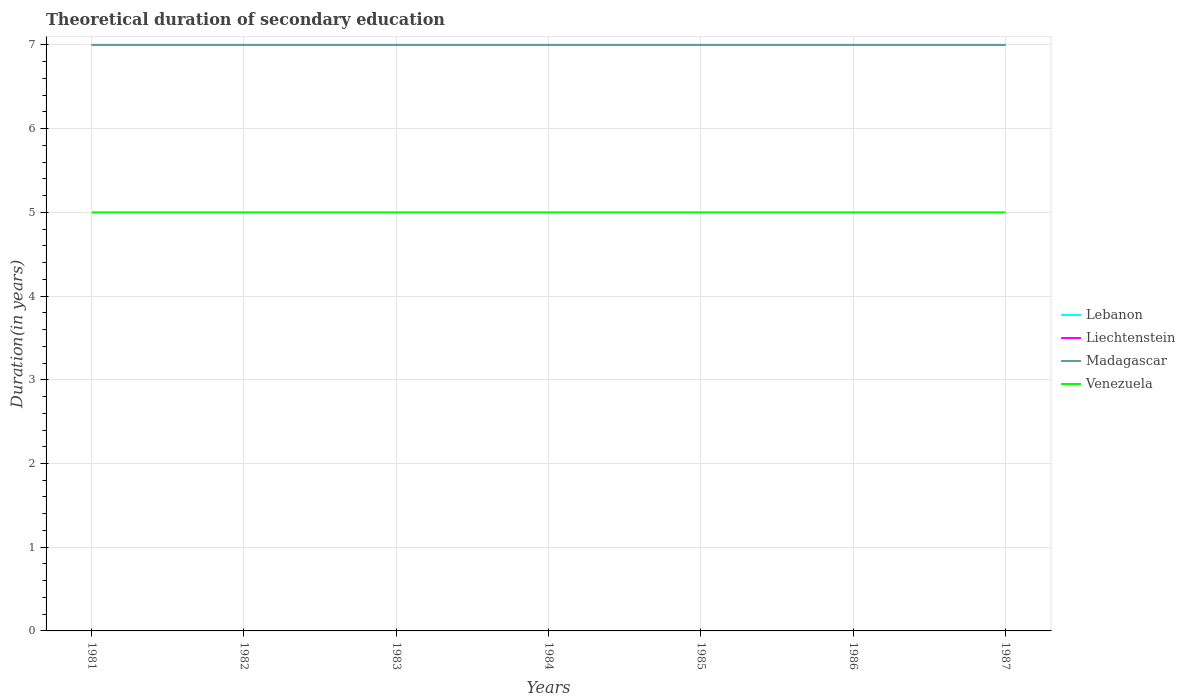How many different coloured lines are there?
Ensure brevity in your answer.  4. Across all years, what is the maximum total theoretical duration of secondary education in Madagascar?
Give a very brief answer. 7. In which year was the total theoretical duration of secondary education in Venezuela maximum?
Provide a succinct answer. 1981. What is the total total theoretical duration of secondary education in Lebanon in the graph?
Your answer should be very brief. 0. What is the difference between the highest and the second highest total theoretical duration of secondary education in Madagascar?
Your response must be concise. 0. What is the difference between the highest and the lowest total theoretical duration of secondary education in Madagascar?
Provide a succinct answer. 0. Is the total theoretical duration of secondary education in Madagascar strictly greater than the total theoretical duration of secondary education in Lebanon over the years?
Ensure brevity in your answer.  No. What is the difference between two consecutive major ticks on the Y-axis?
Give a very brief answer. 1. How are the legend labels stacked?
Give a very brief answer. Vertical. What is the title of the graph?
Your response must be concise. Theoretical duration of secondary education. What is the label or title of the Y-axis?
Offer a terse response. Duration(in years). What is the Duration(in years) of Lebanon in 1981?
Give a very brief answer. 7. What is the Duration(in years) in Madagascar in 1981?
Your answer should be compact. 7. What is the Duration(in years) in Lebanon in 1982?
Provide a short and direct response. 7. What is the Duration(in years) in Liechtenstein in 1982?
Provide a short and direct response. 7. What is the Duration(in years) of Lebanon in 1983?
Offer a terse response. 7. What is the Duration(in years) of Liechtenstein in 1983?
Give a very brief answer. 7. What is the Duration(in years) in Venezuela in 1984?
Your answer should be compact. 5. What is the Duration(in years) of Liechtenstein in 1985?
Give a very brief answer. 7. What is the Duration(in years) of Madagascar in 1985?
Provide a short and direct response. 7. What is the Duration(in years) of Venezuela in 1985?
Ensure brevity in your answer.  5. What is the Duration(in years) of Liechtenstein in 1986?
Make the answer very short. 7. What is the Duration(in years) in Madagascar in 1986?
Offer a terse response. 7. What is the Duration(in years) in Venezuela in 1986?
Offer a very short reply. 5. What is the Duration(in years) in Lebanon in 1987?
Make the answer very short. 7. What is the Duration(in years) of Liechtenstein in 1987?
Your answer should be very brief. 7. What is the Duration(in years) of Venezuela in 1987?
Offer a terse response. 5. Across all years, what is the maximum Duration(in years) in Lebanon?
Give a very brief answer. 7. Across all years, what is the minimum Duration(in years) in Liechtenstein?
Your answer should be compact. 7. Across all years, what is the minimum Duration(in years) of Venezuela?
Give a very brief answer. 5. What is the total Duration(in years) in Lebanon in the graph?
Provide a short and direct response. 49. What is the difference between the Duration(in years) in Lebanon in 1981 and that in 1982?
Give a very brief answer. 0. What is the difference between the Duration(in years) in Liechtenstein in 1981 and that in 1982?
Give a very brief answer. 0. What is the difference between the Duration(in years) in Madagascar in 1981 and that in 1982?
Ensure brevity in your answer.  0. What is the difference between the Duration(in years) of Madagascar in 1981 and that in 1983?
Your response must be concise. 0. What is the difference between the Duration(in years) of Venezuela in 1981 and that in 1983?
Ensure brevity in your answer.  0. What is the difference between the Duration(in years) in Madagascar in 1981 and that in 1984?
Provide a short and direct response. 0. What is the difference between the Duration(in years) in Venezuela in 1981 and that in 1984?
Offer a terse response. 0. What is the difference between the Duration(in years) of Madagascar in 1981 and that in 1985?
Offer a terse response. 0. What is the difference between the Duration(in years) of Venezuela in 1981 and that in 1985?
Provide a succinct answer. 0. What is the difference between the Duration(in years) of Lebanon in 1981 and that in 1986?
Offer a very short reply. 0. What is the difference between the Duration(in years) of Liechtenstein in 1981 and that in 1986?
Offer a very short reply. 0. What is the difference between the Duration(in years) in Lebanon in 1981 and that in 1987?
Offer a very short reply. 0. What is the difference between the Duration(in years) of Liechtenstein in 1981 and that in 1987?
Your answer should be very brief. 0. What is the difference between the Duration(in years) of Lebanon in 1982 and that in 1985?
Keep it short and to the point. 0. What is the difference between the Duration(in years) in Liechtenstein in 1982 and that in 1985?
Provide a succinct answer. 0. What is the difference between the Duration(in years) of Madagascar in 1982 and that in 1985?
Provide a short and direct response. 0. What is the difference between the Duration(in years) in Liechtenstein in 1982 and that in 1986?
Give a very brief answer. 0. What is the difference between the Duration(in years) in Venezuela in 1982 and that in 1986?
Offer a terse response. 0. What is the difference between the Duration(in years) of Liechtenstein in 1982 and that in 1987?
Ensure brevity in your answer.  0. What is the difference between the Duration(in years) of Madagascar in 1982 and that in 1987?
Give a very brief answer. 0. What is the difference between the Duration(in years) of Venezuela in 1982 and that in 1987?
Your response must be concise. 0. What is the difference between the Duration(in years) of Lebanon in 1983 and that in 1984?
Your answer should be very brief. 0. What is the difference between the Duration(in years) of Liechtenstein in 1983 and that in 1984?
Provide a succinct answer. 0. What is the difference between the Duration(in years) in Madagascar in 1983 and that in 1985?
Your answer should be very brief. 0. What is the difference between the Duration(in years) of Venezuela in 1983 and that in 1985?
Provide a short and direct response. 0. What is the difference between the Duration(in years) of Liechtenstein in 1983 and that in 1987?
Your answer should be very brief. 0. What is the difference between the Duration(in years) of Venezuela in 1983 and that in 1987?
Provide a succinct answer. 0. What is the difference between the Duration(in years) of Lebanon in 1984 and that in 1985?
Offer a terse response. 0. What is the difference between the Duration(in years) of Madagascar in 1984 and that in 1985?
Make the answer very short. 0. What is the difference between the Duration(in years) of Liechtenstein in 1984 and that in 1986?
Your answer should be compact. 0. What is the difference between the Duration(in years) in Madagascar in 1984 and that in 1987?
Offer a terse response. 0. What is the difference between the Duration(in years) of Venezuela in 1984 and that in 1987?
Ensure brevity in your answer.  0. What is the difference between the Duration(in years) of Lebanon in 1985 and that in 1986?
Provide a short and direct response. 0. What is the difference between the Duration(in years) in Madagascar in 1985 and that in 1986?
Offer a very short reply. 0. What is the difference between the Duration(in years) of Lebanon in 1985 and that in 1987?
Offer a very short reply. 0. What is the difference between the Duration(in years) in Liechtenstein in 1986 and that in 1987?
Make the answer very short. 0. What is the difference between the Duration(in years) of Venezuela in 1986 and that in 1987?
Ensure brevity in your answer.  0. What is the difference between the Duration(in years) of Lebanon in 1981 and the Duration(in years) of Madagascar in 1982?
Your response must be concise. 0. What is the difference between the Duration(in years) of Lebanon in 1981 and the Duration(in years) of Venezuela in 1982?
Provide a short and direct response. 2. What is the difference between the Duration(in years) of Liechtenstein in 1981 and the Duration(in years) of Madagascar in 1982?
Offer a very short reply. 0. What is the difference between the Duration(in years) in Liechtenstein in 1981 and the Duration(in years) in Venezuela in 1982?
Offer a very short reply. 2. What is the difference between the Duration(in years) in Lebanon in 1981 and the Duration(in years) in Liechtenstein in 1983?
Your answer should be compact. 0. What is the difference between the Duration(in years) of Lebanon in 1981 and the Duration(in years) of Madagascar in 1983?
Your answer should be compact. 0. What is the difference between the Duration(in years) in Lebanon in 1981 and the Duration(in years) in Venezuela in 1983?
Provide a succinct answer. 2. What is the difference between the Duration(in years) of Liechtenstein in 1981 and the Duration(in years) of Venezuela in 1983?
Provide a short and direct response. 2. What is the difference between the Duration(in years) in Madagascar in 1981 and the Duration(in years) in Venezuela in 1983?
Your answer should be very brief. 2. What is the difference between the Duration(in years) in Lebanon in 1981 and the Duration(in years) in Liechtenstein in 1984?
Your answer should be very brief. 0. What is the difference between the Duration(in years) of Liechtenstein in 1981 and the Duration(in years) of Madagascar in 1984?
Provide a short and direct response. 0. What is the difference between the Duration(in years) in Liechtenstein in 1981 and the Duration(in years) in Venezuela in 1984?
Offer a very short reply. 2. What is the difference between the Duration(in years) in Madagascar in 1981 and the Duration(in years) in Venezuela in 1984?
Your answer should be compact. 2. What is the difference between the Duration(in years) in Lebanon in 1981 and the Duration(in years) in Venezuela in 1985?
Ensure brevity in your answer.  2. What is the difference between the Duration(in years) in Liechtenstein in 1981 and the Duration(in years) in Madagascar in 1985?
Keep it short and to the point. 0. What is the difference between the Duration(in years) of Lebanon in 1981 and the Duration(in years) of Madagascar in 1986?
Offer a terse response. 0. What is the difference between the Duration(in years) in Lebanon in 1981 and the Duration(in years) in Venezuela in 1986?
Give a very brief answer. 2. What is the difference between the Duration(in years) in Liechtenstein in 1981 and the Duration(in years) in Madagascar in 1986?
Your answer should be compact. 0. What is the difference between the Duration(in years) in Liechtenstein in 1981 and the Duration(in years) in Madagascar in 1987?
Your response must be concise. 0. What is the difference between the Duration(in years) in Liechtenstein in 1981 and the Duration(in years) in Venezuela in 1987?
Provide a succinct answer. 2. What is the difference between the Duration(in years) in Lebanon in 1982 and the Duration(in years) in Liechtenstein in 1983?
Your answer should be compact. 0. What is the difference between the Duration(in years) in Lebanon in 1982 and the Duration(in years) in Madagascar in 1984?
Your response must be concise. 0. What is the difference between the Duration(in years) in Lebanon in 1982 and the Duration(in years) in Venezuela in 1984?
Your answer should be compact. 2. What is the difference between the Duration(in years) in Liechtenstein in 1982 and the Duration(in years) in Venezuela in 1984?
Your response must be concise. 2. What is the difference between the Duration(in years) of Madagascar in 1982 and the Duration(in years) of Venezuela in 1984?
Give a very brief answer. 2. What is the difference between the Duration(in years) in Lebanon in 1982 and the Duration(in years) in Liechtenstein in 1985?
Make the answer very short. 0. What is the difference between the Duration(in years) of Lebanon in 1982 and the Duration(in years) of Madagascar in 1985?
Make the answer very short. 0. What is the difference between the Duration(in years) of Liechtenstein in 1982 and the Duration(in years) of Madagascar in 1985?
Your answer should be very brief. 0. What is the difference between the Duration(in years) in Madagascar in 1982 and the Duration(in years) in Venezuela in 1985?
Your answer should be very brief. 2. What is the difference between the Duration(in years) of Lebanon in 1982 and the Duration(in years) of Liechtenstein in 1986?
Keep it short and to the point. 0. What is the difference between the Duration(in years) of Lebanon in 1982 and the Duration(in years) of Venezuela in 1986?
Provide a succinct answer. 2. What is the difference between the Duration(in years) in Liechtenstein in 1982 and the Duration(in years) in Venezuela in 1986?
Offer a terse response. 2. What is the difference between the Duration(in years) of Madagascar in 1982 and the Duration(in years) of Venezuela in 1986?
Offer a very short reply. 2. What is the difference between the Duration(in years) of Lebanon in 1982 and the Duration(in years) of Madagascar in 1987?
Give a very brief answer. 0. What is the difference between the Duration(in years) of Liechtenstein in 1982 and the Duration(in years) of Venezuela in 1987?
Offer a terse response. 2. What is the difference between the Duration(in years) of Lebanon in 1983 and the Duration(in years) of Liechtenstein in 1984?
Your answer should be very brief. 0. What is the difference between the Duration(in years) in Lebanon in 1983 and the Duration(in years) in Madagascar in 1984?
Ensure brevity in your answer.  0. What is the difference between the Duration(in years) in Liechtenstein in 1983 and the Duration(in years) in Venezuela in 1984?
Your answer should be compact. 2. What is the difference between the Duration(in years) in Madagascar in 1983 and the Duration(in years) in Venezuela in 1984?
Ensure brevity in your answer.  2. What is the difference between the Duration(in years) in Lebanon in 1983 and the Duration(in years) in Madagascar in 1985?
Your answer should be very brief. 0. What is the difference between the Duration(in years) in Liechtenstein in 1983 and the Duration(in years) in Madagascar in 1985?
Your answer should be compact. 0. What is the difference between the Duration(in years) in Liechtenstein in 1983 and the Duration(in years) in Venezuela in 1985?
Keep it short and to the point. 2. What is the difference between the Duration(in years) of Madagascar in 1983 and the Duration(in years) of Venezuela in 1985?
Your response must be concise. 2. What is the difference between the Duration(in years) in Lebanon in 1983 and the Duration(in years) in Liechtenstein in 1986?
Your answer should be compact. 0. What is the difference between the Duration(in years) in Liechtenstein in 1983 and the Duration(in years) in Madagascar in 1986?
Give a very brief answer. 0. What is the difference between the Duration(in years) in Lebanon in 1983 and the Duration(in years) in Liechtenstein in 1987?
Give a very brief answer. 0. What is the difference between the Duration(in years) in Lebanon in 1983 and the Duration(in years) in Madagascar in 1987?
Make the answer very short. 0. What is the difference between the Duration(in years) in Lebanon in 1983 and the Duration(in years) in Venezuela in 1987?
Your answer should be very brief. 2. What is the difference between the Duration(in years) in Liechtenstein in 1983 and the Duration(in years) in Madagascar in 1987?
Provide a succinct answer. 0. What is the difference between the Duration(in years) of Lebanon in 1984 and the Duration(in years) of Liechtenstein in 1985?
Give a very brief answer. 0. What is the difference between the Duration(in years) in Lebanon in 1984 and the Duration(in years) in Venezuela in 1985?
Keep it short and to the point. 2. What is the difference between the Duration(in years) in Liechtenstein in 1984 and the Duration(in years) in Venezuela in 1985?
Offer a terse response. 2. What is the difference between the Duration(in years) of Lebanon in 1984 and the Duration(in years) of Madagascar in 1986?
Ensure brevity in your answer.  0. What is the difference between the Duration(in years) of Liechtenstein in 1984 and the Duration(in years) of Madagascar in 1986?
Ensure brevity in your answer.  0. What is the difference between the Duration(in years) in Lebanon in 1984 and the Duration(in years) in Venezuela in 1987?
Your response must be concise. 2. What is the difference between the Duration(in years) of Liechtenstein in 1984 and the Duration(in years) of Venezuela in 1987?
Offer a terse response. 2. What is the difference between the Duration(in years) of Madagascar in 1984 and the Duration(in years) of Venezuela in 1987?
Make the answer very short. 2. What is the difference between the Duration(in years) of Lebanon in 1985 and the Duration(in years) of Madagascar in 1986?
Give a very brief answer. 0. What is the difference between the Duration(in years) of Lebanon in 1985 and the Duration(in years) of Venezuela in 1986?
Give a very brief answer. 2. What is the difference between the Duration(in years) of Liechtenstein in 1985 and the Duration(in years) of Venezuela in 1986?
Provide a short and direct response. 2. What is the difference between the Duration(in years) of Madagascar in 1985 and the Duration(in years) of Venezuela in 1986?
Provide a succinct answer. 2. What is the difference between the Duration(in years) in Lebanon in 1985 and the Duration(in years) in Madagascar in 1987?
Ensure brevity in your answer.  0. What is the difference between the Duration(in years) of Liechtenstein in 1985 and the Duration(in years) of Madagascar in 1987?
Give a very brief answer. 0. What is the difference between the Duration(in years) in Liechtenstein in 1985 and the Duration(in years) in Venezuela in 1987?
Make the answer very short. 2. What is the difference between the Duration(in years) in Lebanon in 1986 and the Duration(in years) in Liechtenstein in 1987?
Your answer should be compact. 0. What is the difference between the Duration(in years) of Lebanon in 1986 and the Duration(in years) of Madagascar in 1987?
Your answer should be very brief. 0. What is the average Duration(in years) of Madagascar per year?
Your answer should be very brief. 7. What is the average Duration(in years) in Venezuela per year?
Offer a terse response. 5. In the year 1981, what is the difference between the Duration(in years) in Lebanon and Duration(in years) in Madagascar?
Your answer should be very brief. 0. In the year 1981, what is the difference between the Duration(in years) of Lebanon and Duration(in years) of Venezuela?
Provide a short and direct response. 2. In the year 1981, what is the difference between the Duration(in years) in Liechtenstein and Duration(in years) in Madagascar?
Your response must be concise. 0. In the year 1982, what is the difference between the Duration(in years) of Lebanon and Duration(in years) of Liechtenstein?
Provide a succinct answer. 0. In the year 1982, what is the difference between the Duration(in years) in Lebanon and Duration(in years) in Venezuela?
Offer a very short reply. 2. In the year 1982, what is the difference between the Duration(in years) of Liechtenstein and Duration(in years) of Madagascar?
Make the answer very short. 0. In the year 1982, what is the difference between the Duration(in years) in Liechtenstein and Duration(in years) in Venezuela?
Keep it short and to the point. 2. In the year 1983, what is the difference between the Duration(in years) in Lebanon and Duration(in years) in Madagascar?
Keep it short and to the point. 0. In the year 1983, what is the difference between the Duration(in years) in Lebanon and Duration(in years) in Venezuela?
Give a very brief answer. 2. In the year 1983, what is the difference between the Duration(in years) in Liechtenstein and Duration(in years) in Venezuela?
Provide a short and direct response. 2. In the year 1983, what is the difference between the Duration(in years) of Madagascar and Duration(in years) of Venezuela?
Your answer should be very brief. 2. In the year 1984, what is the difference between the Duration(in years) in Lebanon and Duration(in years) in Liechtenstein?
Provide a succinct answer. 0. In the year 1984, what is the difference between the Duration(in years) in Lebanon and Duration(in years) in Venezuela?
Keep it short and to the point. 2. In the year 1984, what is the difference between the Duration(in years) in Liechtenstein and Duration(in years) in Venezuela?
Provide a succinct answer. 2. In the year 1984, what is the difference between the Duration(in years) of Madagascar and Duration(in years) of Venezuela?
Give a very brief answer. 2. In the year 1985, what is the difference between the Duration(in years) in Lebanon and Duration(in years) in Liechtenstein?
Ensure brevity in your answer.  0. In the year 1985, what is the difference between the Duration(in years) in Lebanon and Duration(in years) in Madagascar?
Make the answer very short. 0. In the year 1985, what is the difference between the Duration(in years) in Lebanon and Duration(in years) in Venezuela?
Keep it short and to the point. 2. In the year 1985, what is the difference between the Duration(in years) of Liechtenstein and Duration(in years) of Venezuela?
Offer a very short reply. 2. In the year 1985, what is the difference between the Duration(in years) of Madagascar and Duration(in years) of Venezuela?
Give a very brief answer. 2. In the year 1986, what is the difference between the Duration(in years) of Lebanon and Duration(in years) of Liechtenstein?
Provide a short and direct response. 0. In the year 1986, what is the difference between the Duration(in years) of Lebanon and Duration(in years) of Venezuela?
Provide a succinct answer. 2. In the year 1986, what is the difference between the Duration(in years) in Liechtenstein and Duration(in years) in Madagascar?
Offer a very short reply. 0. In the year 1986, what is the difference between the Duration(in years) in Liechtenstein and Duration(in years) in Venezuela?
Keep it short and to the point. 2. In the year 1986, what is the difference between the Duration(in years) in Madagascar and Duration(in years) in Venezuela?
Your response must be concise. 2. In the year 1987, what is the difference between the Duration(in years) in Lebanon and Duration(in years) in Venezuela?
Keep it short and to the point. 2. In the year 1987, what is the difference between the Duration(in years) of Liechtenstein and Duration(in years) of Madagascar?
Provide a short and direct response. 0. In the year 1987, what is the difference between the Duration(in years) in Liechtenstein and Duration(in years) in Venezuela?
Ensure brevity in your answer.  2. What is the ratio of the Duration(in years) in Madagascar in 1981 to that in 1982?
Your answer should be very brief. 1. What is the ratio of the Duration(in years) in Venezuela in 1981 to that in 1982?
Give a very brief answer. 1. What is the ratio of the Duration(in years) in Lebanon in 1981 to that in 1983?
Your answer should be compact. 1. What is the ratio of the Duration(in years) in Venezuela in 1981 to that in 1983?
Offer a terse response. 1. What is the ratio of the Duration(in years) in Lebanon in 1981 to that in 1984?
Provide a succinct answer. 1. What is the ratio of the Duration(in years) in Madagascar in 1981 to that in 1984?
Your answer should be compact. 1. What is the ratio of the Duration(in years) in Lebanon in 1981 to that in 1985?
Offer a very short reply. 1. What is the ratio of the Duration(in years) in Venezuela in 1981 to that in 1986?
Offer a terse response. 1. What is the ratio of the Duration(in years) in Lebanon in 1981 to that in 1987?
Offer a very short reply. 1. What is the ratio of the Duration(in years) of Liechtenstein in 1981 to that in 1987?
Make the answer very short. 1. What is the ratio of the Duration(in years) of Venezuela in 1981 to that in 1987?
Ensure brevity in your answer.  1. What is the ratio of the Duration(in years) of Lebanon in 1982 to that in 1983?
Keep it short and to the point. 1. What is the ratio of the Duration(in years) in Madagascar in 1982 to that in 1983?
Your answer should be very brief. 1. What is the ratio of the Duration(in years) of Venezuela in 1982 to that in 1983?
Your answer should be very brief. 1. What is the ratio of the Duration(in years) of Liechtenstein in 1982 to that in 1984?
Keep it short and to the point. 1. What is the ratio of the Duration(in years) in Madagascar in 1982 to that in 1984?
Keep it short and to the point. 1. What is the ratio of the Duration(in years) in Venezuela in 1982 to that in 1985?
Your answer should be very brief. 1. What is the ratio of the Duration(in years) in Lebanon in 1982 to that in 1986?
Provide a succinct answer. 1. What is the ratio of the Duration(in years) in Madagascar in 1982 to that in 1986?
Your answer should be compact. 1. What is the ratio of the Duration(in years) of Venezuela in 1982 to that in 1986?
Keep it short and to the point. 1. What is the ratio of the Duration(in years) in Lebanon in 1982 to that in 1987?
Provide a succinct answer. 1. What is the ratio of the Duration(in years) of Liechtenstein in 1982 to that in 1987?
Your response must be concise. 1. What is the ratio of the Duration(in years) of Madagascar in 1982 to that in 1987?
Provide a short and direct response. 1. What is the ratio of the Duration(in years) in Venezuela in 1982 to that in 1987?
Keep it short and to the point. 1. What is the ratio of the Duration(in years) of Madagascar in 1983 to that in 1985?
Ensure brevity in your answer.  1. What is the ratio of the Duration(in years) of Venezuela in 1983 to that in 1985?
Provide a succinct answer. 1. What is the ratio of the Duration(in years) of Liechtenstein in 1983 to that in 1986?
Give a very brief answer. 1. What is the ratio of the Duration(in years) of Venezuela in 1983 to that in 1986?
Offer a very short reply. 1. What is the ratio of the Duration(in years) of Lebanon in 1983 to that in 1987?
Offer a terse response. 1. What is the ratio of the Duration(in years) of Lebanon in 1984 to that in 1986?
Keep it short and to the point. 1. What is the ratio of the Duration(in years) of Liechtenstein in 1984 to that in 1986?
Keep it short and to the point. 1. What is the ratio of the Duration(in years) of Venezuela in 1984 to that in 1986?
Provide a succinct answer. 1. What is the ratio of the Duration(in years) of Liechtenstein in 1984 to that in 1987?
Keep it short and to the point. 1. What is the ratio of the Duration(in years) of Lebanon in 1985 to that in 1986?
Offer a very short reply. 1. What is the ratio of the Duration(in years) in Liechtenstein in 1985 to that in 1986?
Ensure brevity in your answer.  1. What is the ratio of the Duration(in years) of Venezuela in 1985 to that in 1986?
Ensure brevity in your answer.  1. What is the ratio of the Duration(in years) of Lebanon in 1985 to that in 1987?
Your answer should be compact. 1. What is the ratio of the Duration(in years) of Madagascar in 1985 to that in 1987?
Keep it short and to the point. 1. What is the ratio of the Duration(in years) of Venezuela in 1986 to that in 1987?
Provide a succinct answer. 1. What is the difference between the highest and the second highest Duration(in years) in Lebanon?
Keep it short and to the point. 0. What is the difference between the highest and the lowest Duration(in years) in Lebanon?
Provide a short and direct response. 0. What is the difference between the highest and the lowest Duration(in years) of Madagascar?
Your answer should be very brief. 0. 